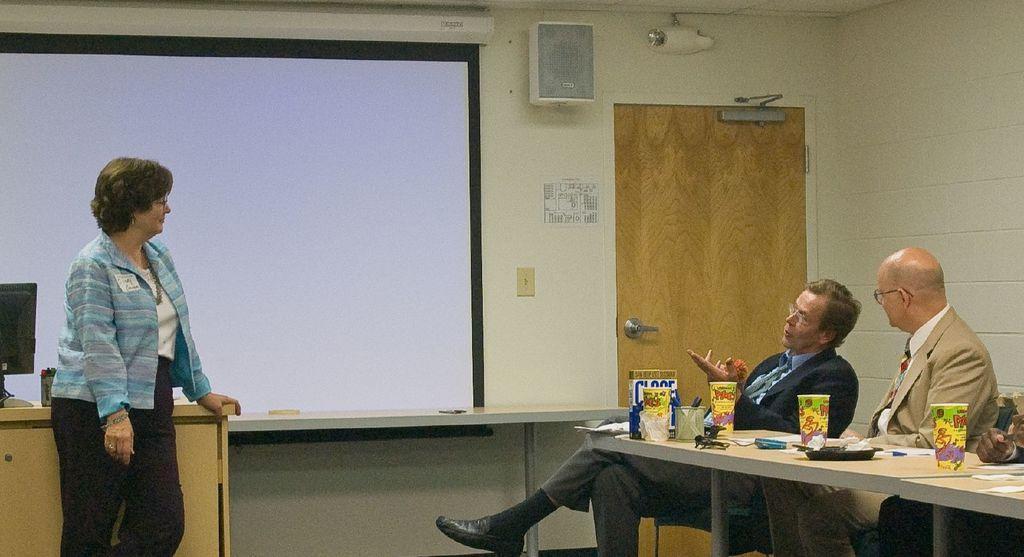In one or two sentences, can you explain what this image depicts? There are three people in a room. On the right side we have a two persons. They are sitting on a chair. On the left side we have a woman. She is standing. There is a table. There is a cup,pen,paper on a table. We can in background projector and door. 